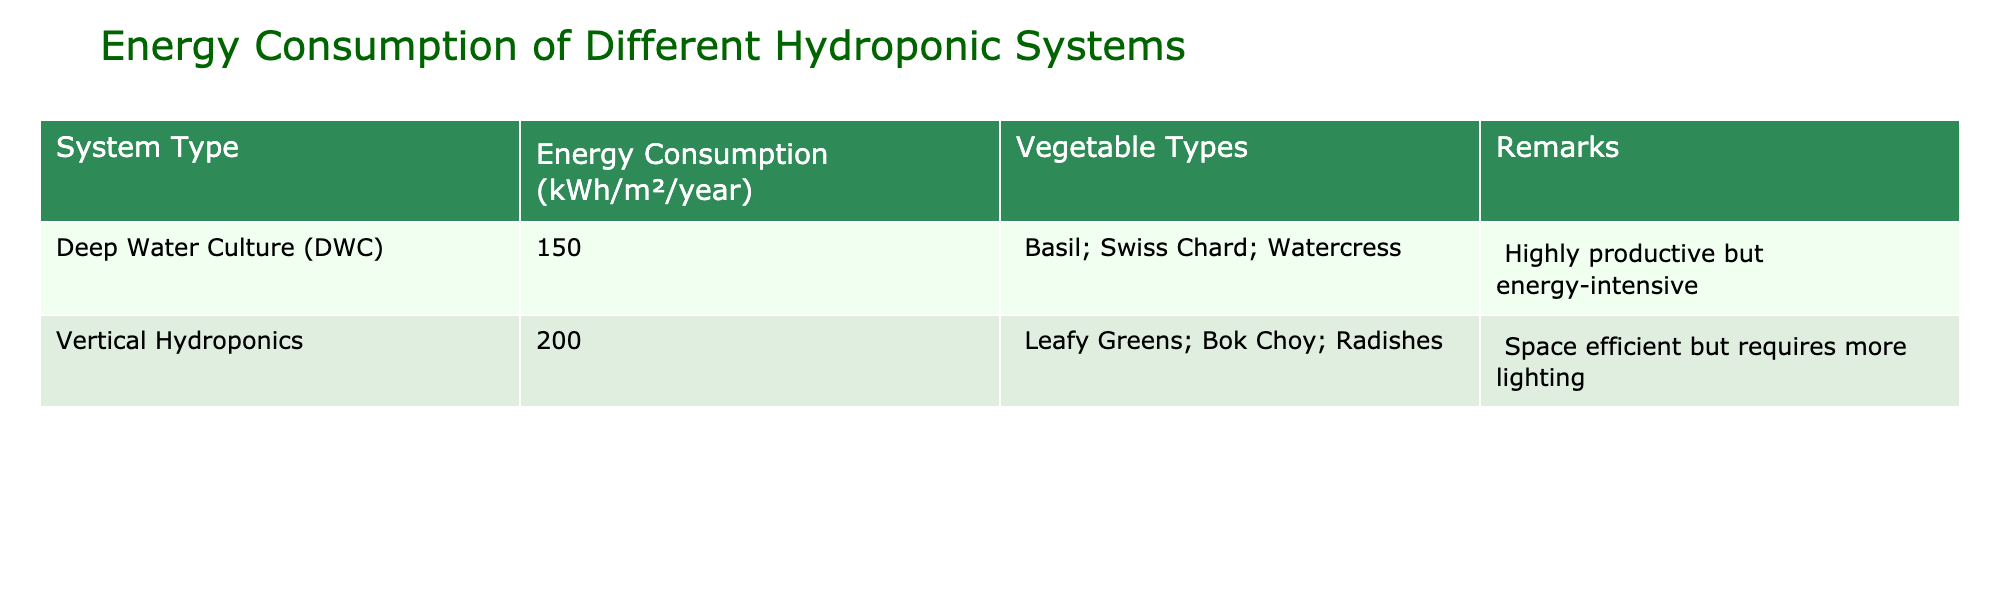What is the energy consumption of the Vertical Hydroponics system? The table shows that the energy consumption for the Vertical Hydroponics system is 200 kWh/m²/year.
Answer: 200 kWh/m²/year Which hydroponic system has the lowest energy consumption? Comparing the energy consumption values in the table, Deep Water Culture has 150 kWh/m²/year, which is less than Vertical Hydroponics at 200 kWh/m²/year.
Answer: Deep Water Culture What types of vegetables are grown in the Deep Water Culture system? The table indicates that the types of vegetables grown in the Deep Water Culture system include Basil, Swiss Chard, and Watercress.
Answer: Basil, Swiss Chard, Watercress Is Vertical Hydroponics more energy-efficient than Deep Water Culture? Vertical Hydroponics has a higher energy consumption of 200 kWh/m²/year compared to Deep Water Culture's 150 kWh/m²/year, indicating it is less energy-efficient.
Answer: No What is the total energy consumption of both hydroponic systems combined? To find the total energy consumption, add the values: 150 kWh/m²/year (DWC) + 200 kWh/m²/year (Vertical Hydroponics) = 350 kWh/m²/year.
Answer: 350 kWh/m²/year What vegetable types are associated with higher energy consumption systems? The Vertical Hydroponics system, which consumes 200 kWh/m²/year, grows Leafy Greens, Bok Choy, and Radishes. This is the system with higher energy consumption compared to Deep Water Culture.
Answer: Leafy Greens, Bok Choy, Radishes If space efficiency is required, which hydroponic system should be chosen? The table notes that Vertical Hydroponics is space efficient, making it the preferred option for situations where space saving is critical.
Answer: Vertical Hydroponics What is the difference in energy consumption between the two systems? The difference is calculated as follows: 200 kWh/m²/year (Vertical Hydroponics) - 150 kWh/m²/year (Deep Water Culture) = 50 kWh/m²/year.
Answer: 50 kWh/m²/year Are both hydroponic systems suitable for leafy greens? While Vertical Hydroponics specifically lists leafy greens, the table does not mention them as being suitable for Deep Water Culture, which focuses on other vegetables.
Answer: Yes, for Vertical Hydroponics only What system is described as highly productive? The table indicates that Deep Water Culture is highly productive, making it a preferred choice despite its energy intensity.
Answer: Deep Water Culture 